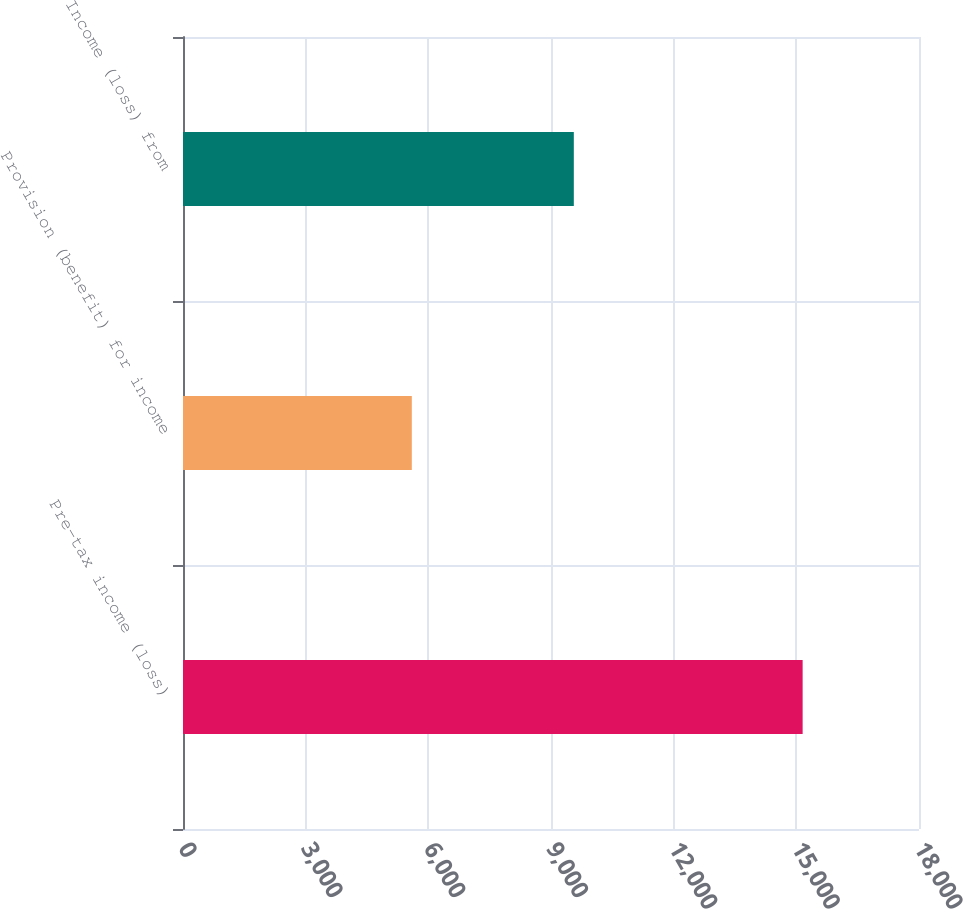Convert chart. <chart><loc_0><loc_0><loc_500><loc_500><bar_chart><fcel>Pre-tax income (loss)<fcel>Provision (benefit) for income<fcel>Income (loss) from<nl><fcel>15154<fcel>5596<fcel>9558<nl></chart> 